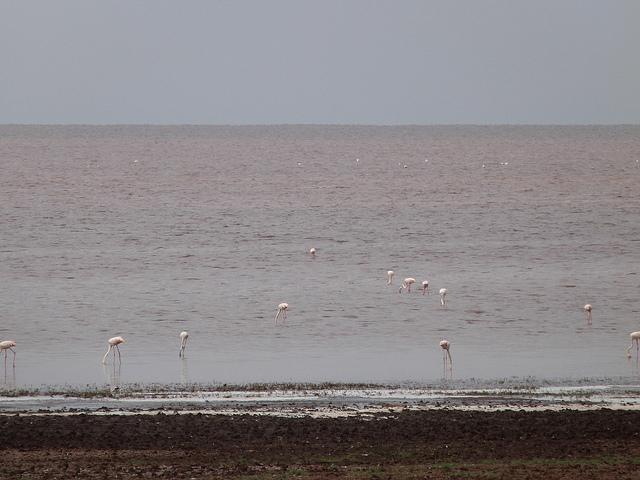What color will these birds become?

Choices:
A) white
B) bright pink
C) black
D) green bright pink 